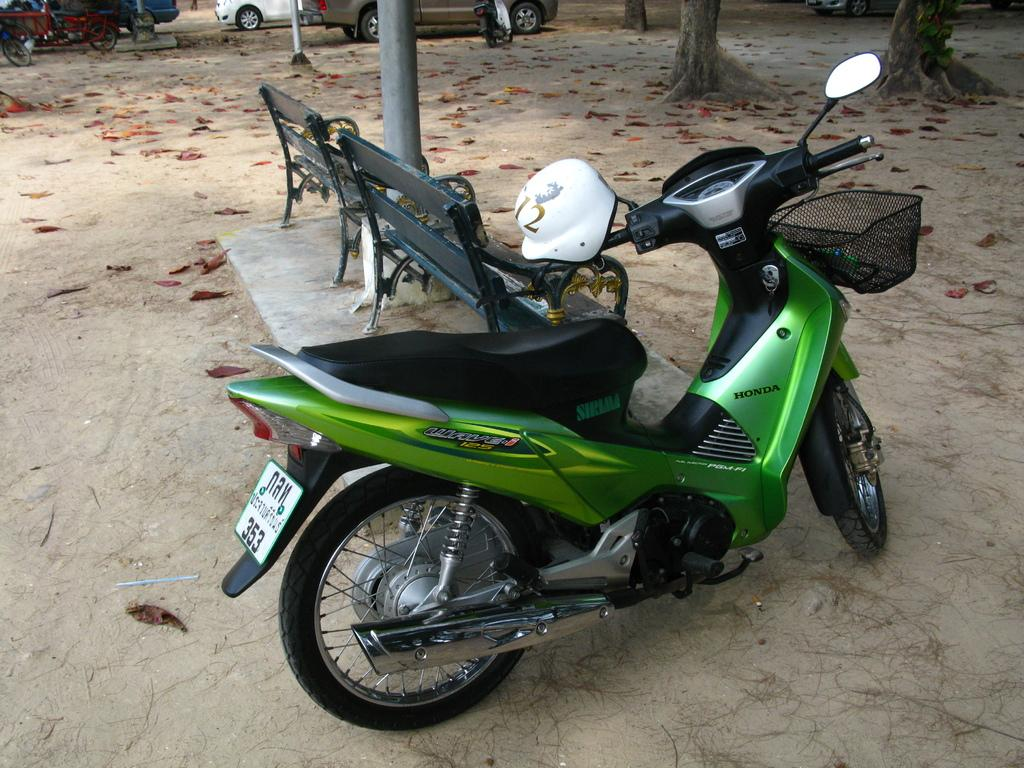What is the main subject in the center of the image? There is a bike in the center of the image. What can be seen in the background of the image? There are tree trunks, benches, bicycles, and vehicles on the road in the background. Can you describe the setting of the image? The image appears to be set in an outdoor area with trees, benches, and bicycles, as well as a road with vehicles in the background. What type of bait is being used to catch the beast in the image? There is no bait or beast present in the image; it features a bike and various background elements. 